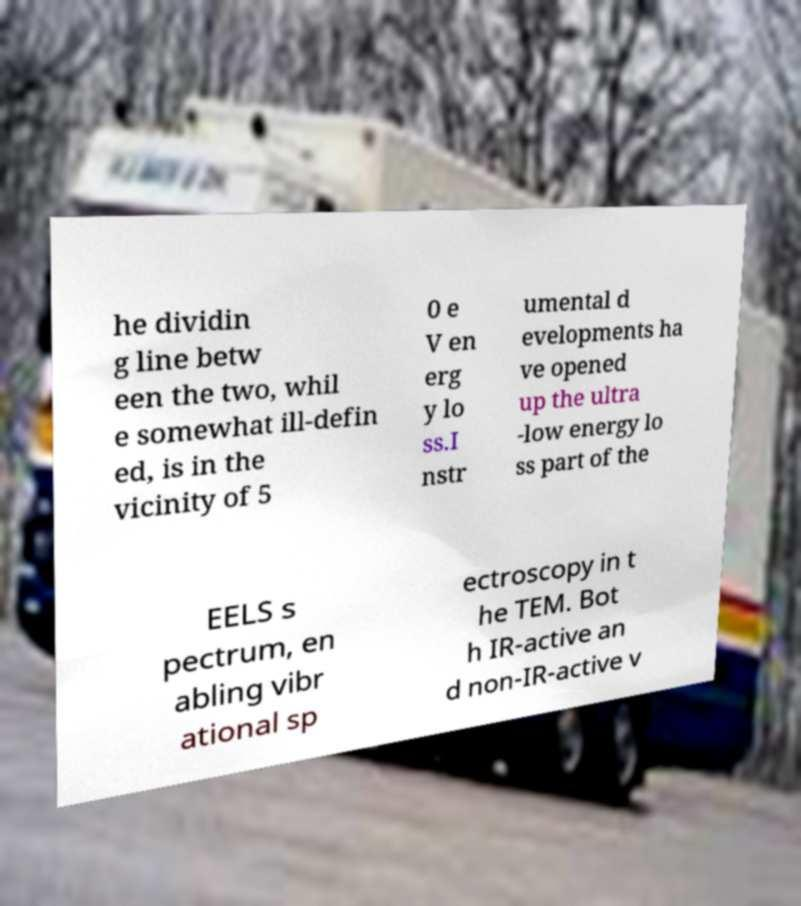Can you accurately transcribe the text from the provided image for me? he dividin g line betw een the two, whil e somewhat ill-defin ed, is in the vicinity of 5 0 e V en erg y lo ss.I nstr umental d evelopments ha ve opened up the ultra -low energy lo ss part of the EELS s pectrum, en abling vibr ational sp ectroscopy in t he TEM. Bot h IR-active an d non-IR-active v 